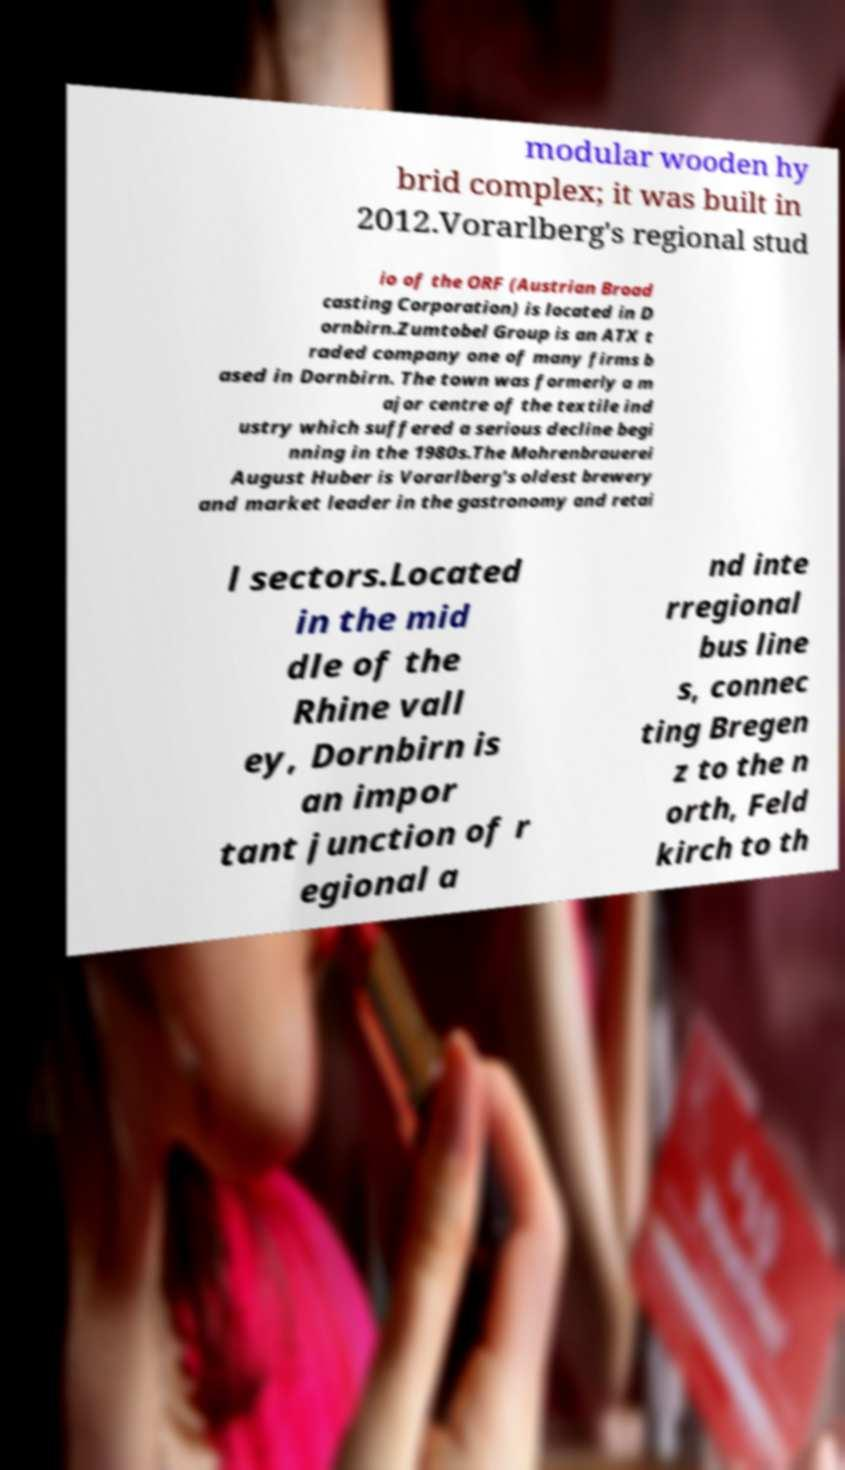Can you read and provide the text displayed in the image?This photo seems to have some interesting text. Can you extract and type it out for me? modular wooden hy brid complex; it was built in 2012.Vorarlberg's regional stud io of the ORF (Austrian Broad casting Corporation) is located in D ornbirn.Zumtobel Group is an ATX t raded company one of many firms b ased in Dornbirn. The town was formerly a m ajor centre of the textile ind ustry which suffered a serious decline begi nning in the 1980s.The Mohrenbrauerei August Huber is Vorarlberg's oldest brewery and market leader in the gastronomy and retai l sectors.Located in the mid dle of the Rhine vall ey, Dornbirn is an impor tant junction of r egional a nd inte rregional bus line s, connec ting Bregen z to the n orth, Feld kirch to th 